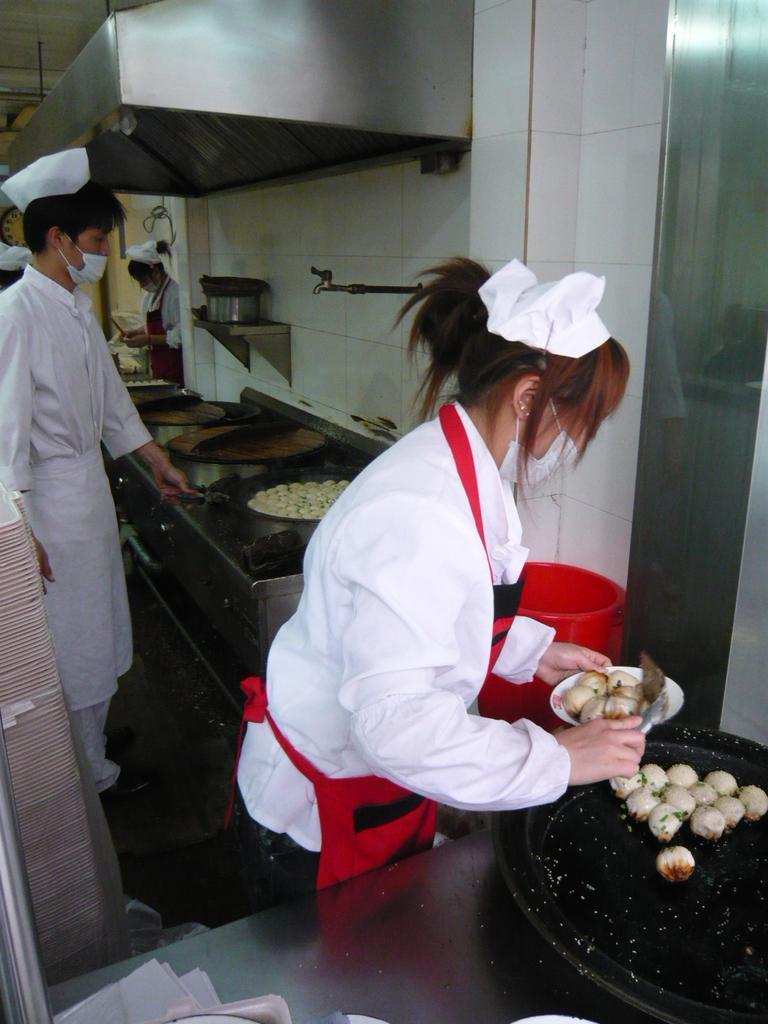Describe this image in one or two sentences. In this image there are persons standing in the center. In the front there is a woman standing and holding a bowl and inside the bowl there is food. In front of the woman there is a pan and on the pan there is some food. The man in the center is standing and holding a pan in his hand. On the top there is a chimney. On the wall there is a tap and the shelf. On the left side there is an object which is white in colour. 